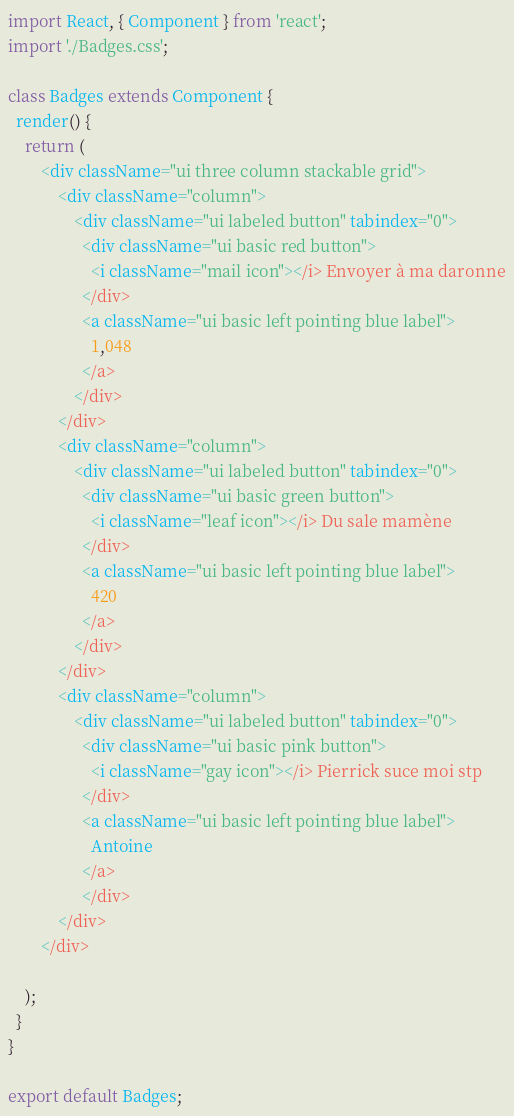<code> <loc_0><loc_0><loc_500><loc_500><_JavaScript_>import React, { Component } from 'react';
import './Badges.css';

class Badges extends Component {
  render() {
    return (
        <div className="ui three column stackable grid">
            <div className="column">
                <div className="ui labeled button" tabindex="0">
                  <div className="ui basic red button">
                    <i className="mail icon"></i> Envoyer à ma daronne
                  </div>
                  <a className="ui basic left pointing blue label">
                    1,048
                  </a>
                </div>
            </div>
            <div className="column">
                <div className="ui labeled button" tabindex="0">
                  <div className="ui basic green button">
                    <i className="leaf icon"></i> Du sale mamène
                  </div>
                  <a className="ui basic left pointing blue label">
                    420
                  </a>
                </div>
            </div>
            <div className="column">
                <div className="ui labeled button" tabindex="0">
                  <div className="ui basic pink button">
                    <i className="gay icon"></i> Pierrick suce moi stp
                  </div>
                  <a className="ui basic left pointing blue label">
                    Antoine
                  </a>
                  </div>
            </div>
        </div>

    );
  }
}

export default Badges;
</code> 